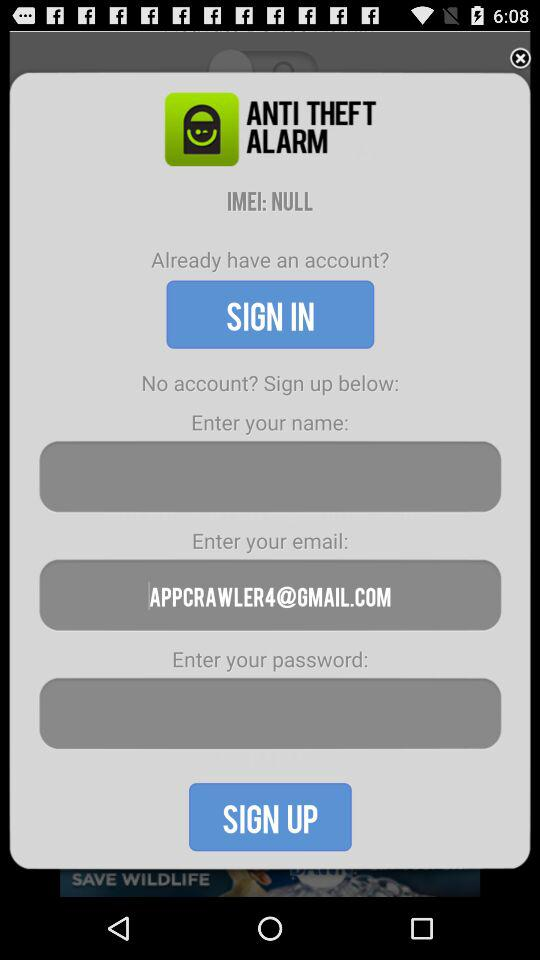What is the application name? The application name is "ANTI THEFT ALARM". 